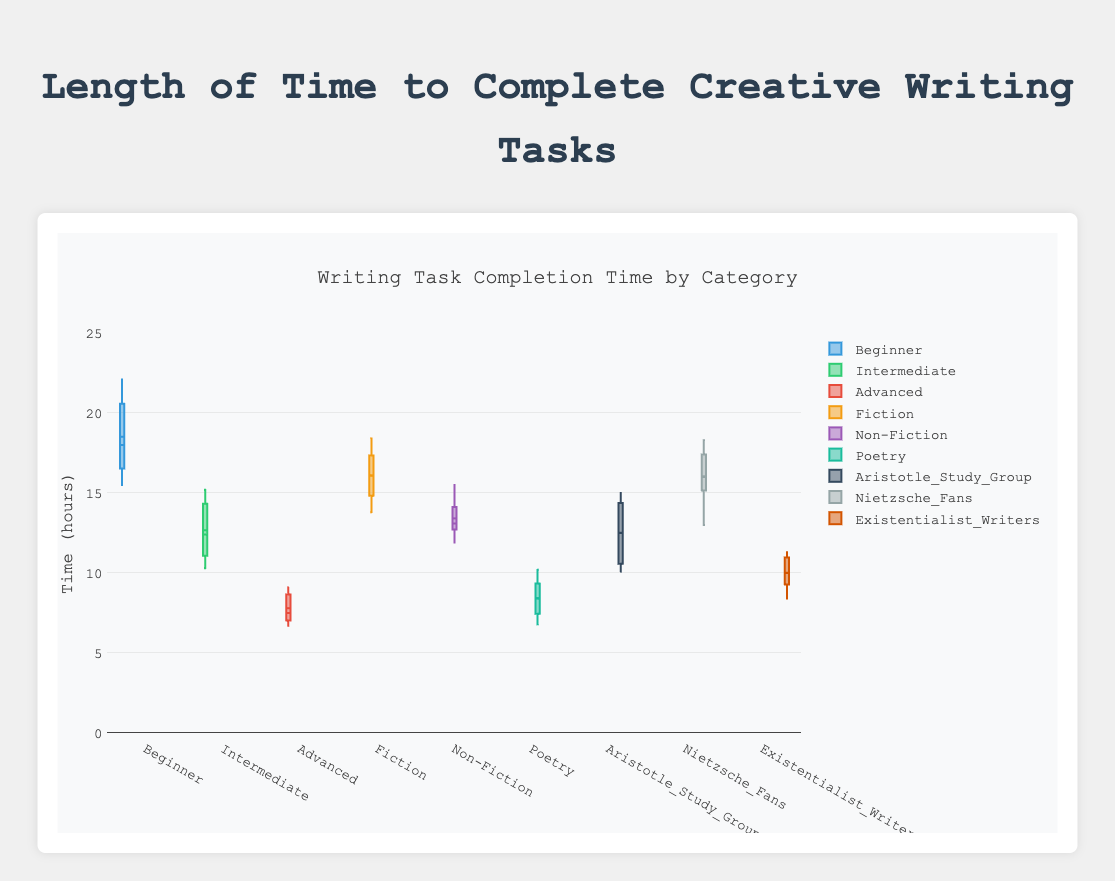What is the title of the plot? The title is displayed at the top center of the plot.
Answer: Writing Task Completion Time by Category What is the y-axis labeled as? The y-axis label is found on the left side vertically, indicating the measurement unit.
Answer: Time (hours) Which color represents "Nietzsche_Fans"? Count the traces while matching the corresponding data points to the "Nietzsche_Fans" group color.
Answer: #f39c12 (fourth group color) Which group has the highest median completion time in the "Aspiring_writer" category? Look at the position of the median line within each boxplot under the category "Aspiring_writer".
Answer: Beginner What is the interquartile range (IQR) for the "Fiction" genre? Identify the 25th percentile (bottom of the box) and the 75th percentile (top of the box), then subtract to find the IQR. The 25th percentile is around 14.7, and the 75th is around 17.5, so IQR is 17.5 - 14.7.
Answer: 2.8 hours Which study cohort shows the most variability in completion times? The variability can be judged by the range between the whiskers of each boxplot.
Answer: Nietzsche_Fans What is the median completion time for "Advanced" writers? Find the line inside the "Advanced" boxplot, which represents the median value.
Answer: 7.5 hours Compare the median completion times for "Fiction" and "Poetry" genres. Which is higher? Identify the median lines within the boxplots for both "Fiction" and "Poetry" genres and compare their positions.
Answer: Fiction Which category has the overall shortest median task completion time? Compare the median lines across all boxplots in each category: "Aspiring_writer", "Genre_Consistency", and "Study_Coherts".
Answer: Advanced (Aspiring_writer) Which subcategory has an outlier above 20 hours? Specifically look for points outside the whiskers and higher than 20 hours across all subcategories.
Answer: Beginner (Aspiring_writer) 